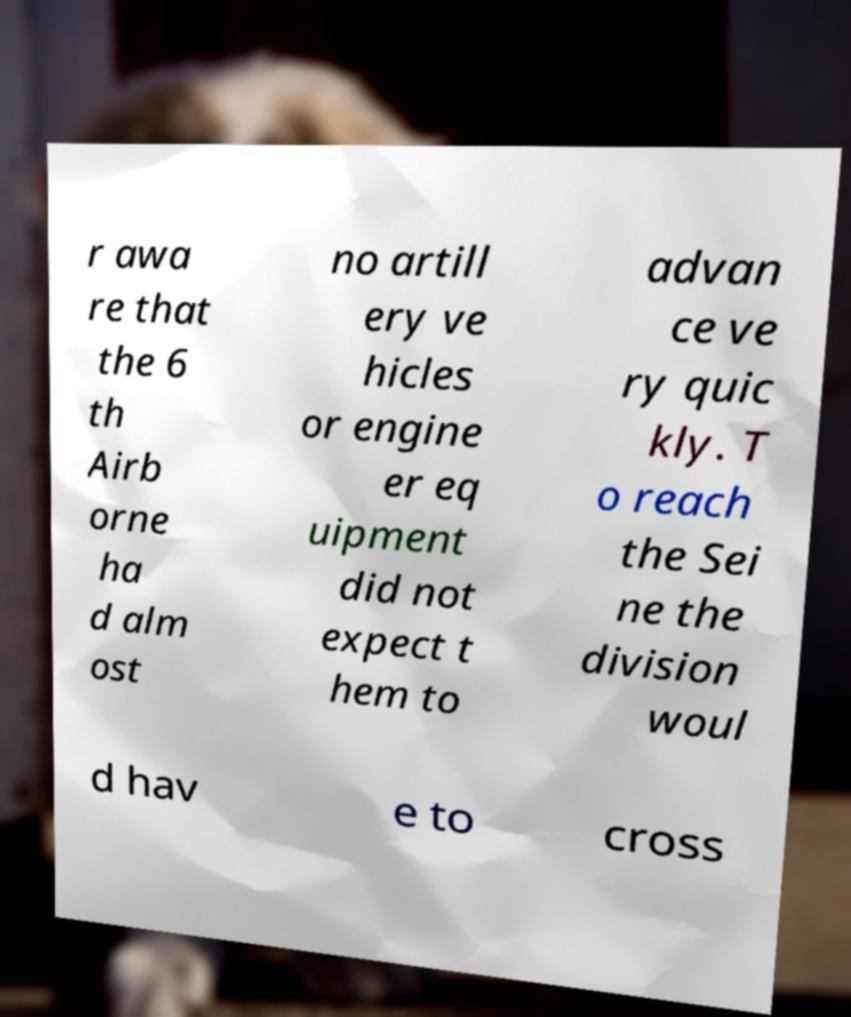There's text embedded in this image that I need extracted. Can you transcribe it verbatim? r awa re that the 6 th Airb orne ha d alm ost no artill ery ve hicles or engine er eq uipment did not expect t hem to advan ce ve ry quic kly. T o reach the Sei ne the division woul d hav e to cross 